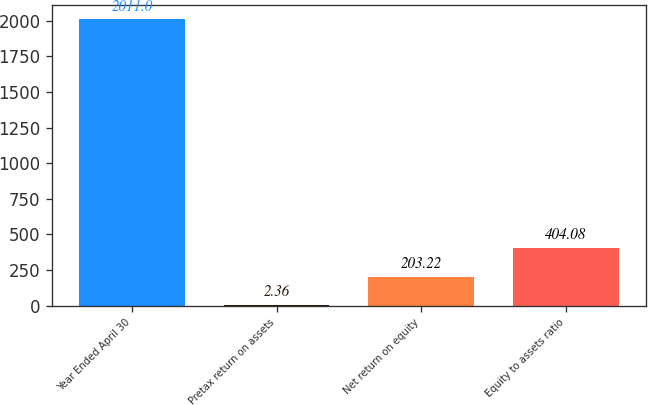Convert chart to OTSL. <chart><loc_0><loc_0><loc_500><loc_500><bar_chart><fcel>Year Ended April 30<fcel>Pretax return on assets<fcel>Net return on equity<fcel>Equity to assets ratio<nl><fcel>2011<fcel>2.36<fcel>203.22<fcel>404.08<nl></chart> 